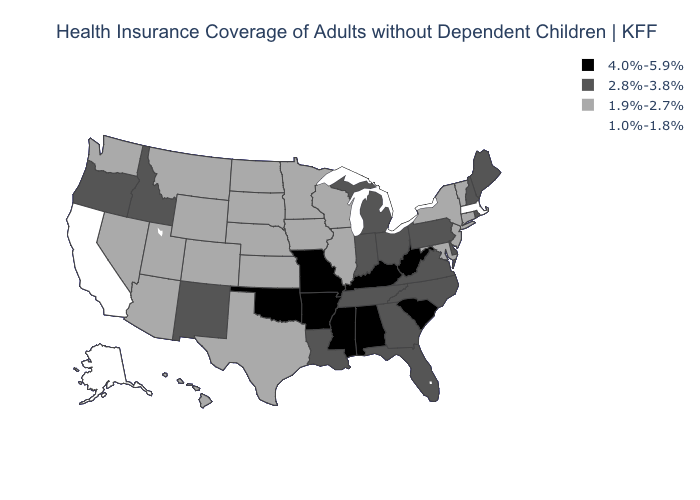Does the first symbol in the legend represent the smallest category?
Short answer required. No. What is the value of Mississippi?
Answer briefly. 4.0%-5.9%. Does Minnesota have the lowest value in the MidWest?
Write a very short answer. Yes. What is the value of Connecticut?
Keep it brief. 1.9%-2.7%. Among the states that border Missouri , which have the lowest value?
Concise answer only. Illinois, Iowa, Kansas, Nebraska. Name the states that have a value in the range 1.0%-1.8%?
Be succinct. Alaska, California, Massachusetts. Name the states that have a value in the range 4.0%-5.9%?
Keep it brief. Alabama, Arkansas, Kentucky, Mississippi, Missouri, Oklahoma, South Carolina, West Virginia. Which states have the lowest value in the USA?
Write a very short answer. Alaska, California, Massachusetts. Does Nebraska have a lower value than Alaska?
Be succinct. No. Name the states that have a value in the range 1.9%-2.7%?
Concise answer only. Arizona, Colorado, Connecticut, Hawaii, Illinois, Iowa, Kansas, Maryland, Minnesota, Montana, Nebraska, Nevada, New Jersey, New York, North Dakota, South Dakota, Texas, Utah, Vermont, Washington, Wisconsin, Wyoming. What is the value of Illinois?
Concise answer only. 1.9%-2.7%. What is the value of New York?
Short answer required. 1.9%-2.7%. What is the highest value in the USA?
Be succinct. 4.0%-5.9%. Does Mississippi have the highest value in the USA?
Concise answer only. Yes. 